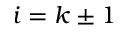<formula> <loc_0><loc_0><loc_500><loc_500>i = k \pm 1</formula> 